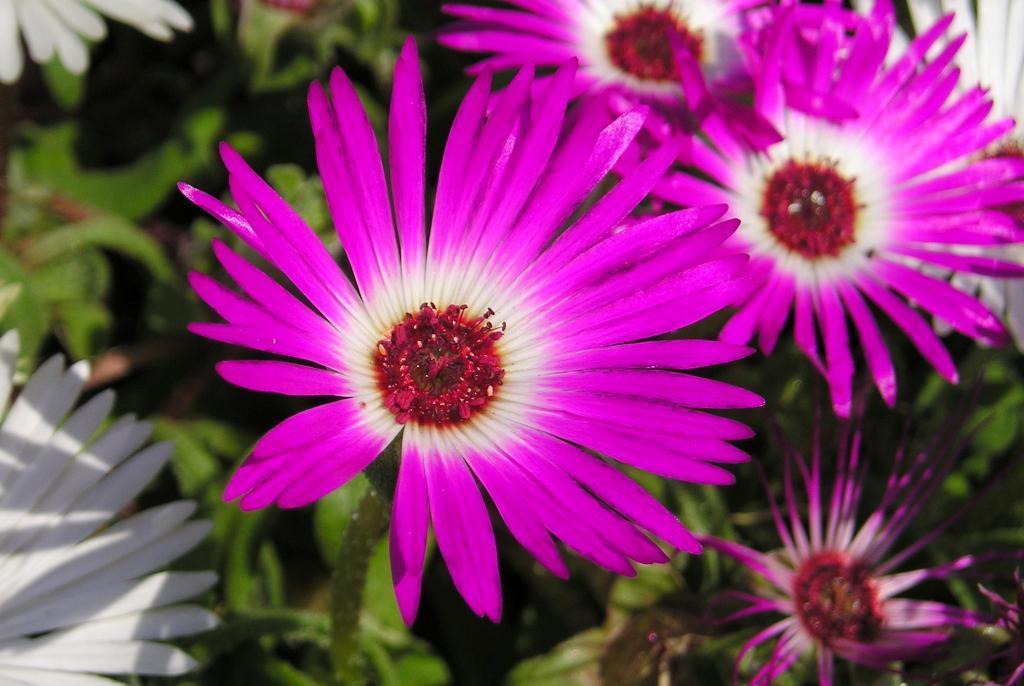Can you describe this image briefly? Here we can see planets with different colors of flowers. 